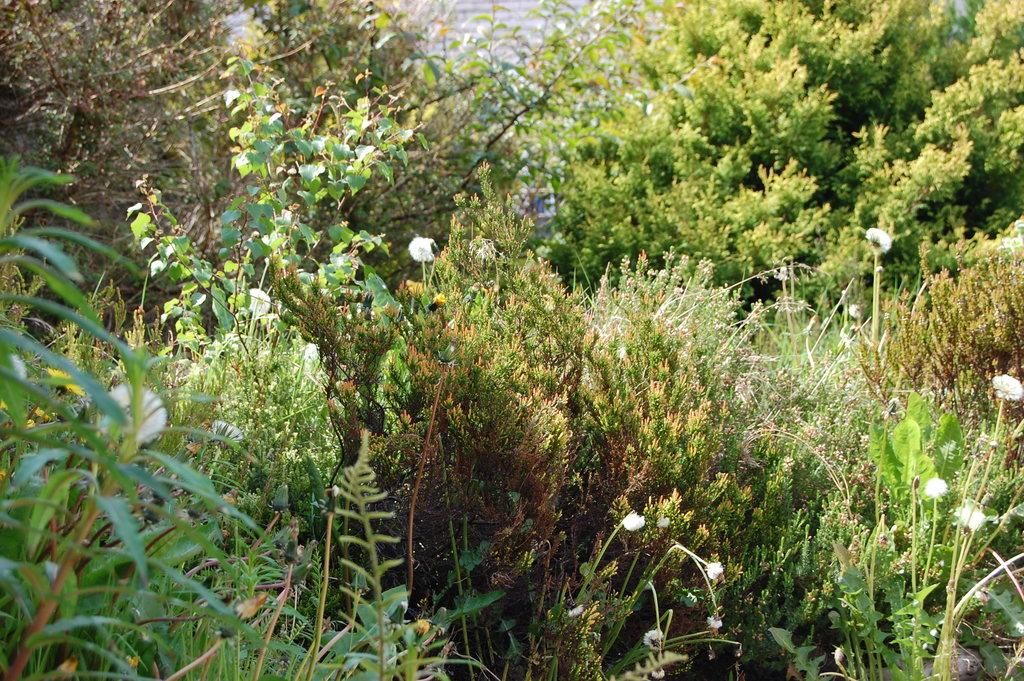What type of vegetation can be seen in the image? There are trees in the image. What colors are the trees in the image? The trees are green and brown in color. What other natural elements can be seen in the image? There are flowers in the image. What color are the flowers in the image? The flowers are white in color. What type of crime is being committed in the image? There is no crime present in the image; it features trees and flowers. Can you see any fangs on the trees or flowers in the image? There are no fangs present on the trees or flowers in the image. 